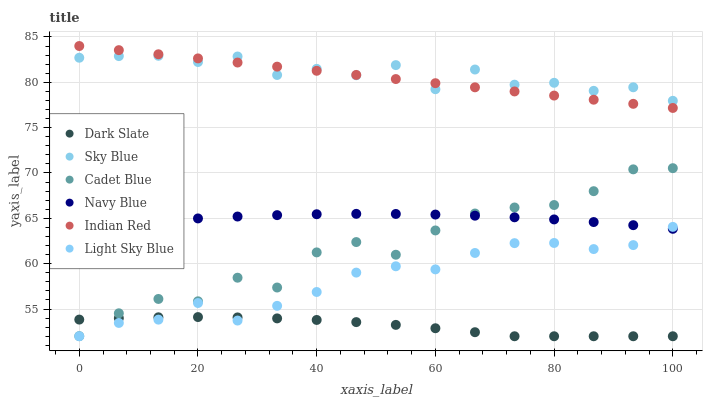Does Dark Slate have the minimum area under the curve?
Answer yes or no. Yes. Does Sky Blue have the maximum area under the curve?
Answer yes or no. Yes. Does Navy Blue have the minimum area under the curve?
Answer yes or no. No. Does Navy Blue have the maximum area under the curve?
Answer yes or no. No. Is Indian Red the smoothest?
Answer yes or no. Yes. Is Cadet Blue the roughest?
Answer yes or no. Yes. Is Navy Blue the smoothest?
Answer yes or no. No. Is Navy Blue the roughest?
Answer yes or no. No. Does Dark Slate have the lowest value?
Answer yes or no. Yes. Does Navy Blue have the lowest value?
Answer yes or no. No. Does Indian Red have the highest value?
Answer yes or no. Yes. Does Navy Blue have the highest value?
Answer yes or no. No. Is Light Sky Blue less than Sky Blue?
Answer yes or no. Yes. Is Navy Blue greater than Dark Slate?
Answer yes or no. Yes. Does Sky Blue intersect Indian Red?
Answer yes or no. Yes. Is Sky Blue less than Indian Red?
Answer yes or no. No. Is Sky Blue greater than Indian Red?
Answer yes or no. No. Does Light Sky Blue intersect Sky Blue?
Answer yes or no. No. 